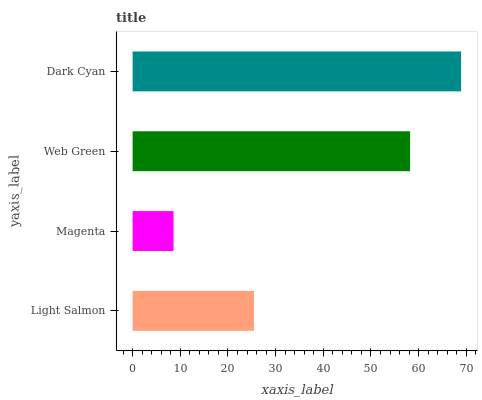Is Magenta the minimum?
Answer yes or no. Yes. Is Dark Cyan the maximum?
Answer yes or no. Yes. Is Web Green the minimum?
Answer yes or no. No. Is Web Green the maximum?
Answer yes or no. No. Is Web Green greater than Magenta?
Answer yes or no. Yes. Is Magenta less than Web Green?
Answer yes or no. Yes. Is Magenta greater than Web Green?
Answer yes or no. No. Is Web Green less than Magenta?
Answer yes or no. No. Is Web Green the high median?
Answer yes or no. Yes. Is Light Salmon the low median?
Answer yes or no. Yes. Is Dark Cyan the high median?
Answer yes or no. No. Is Dark Cyan the low median?
Answer yes or no. No. 